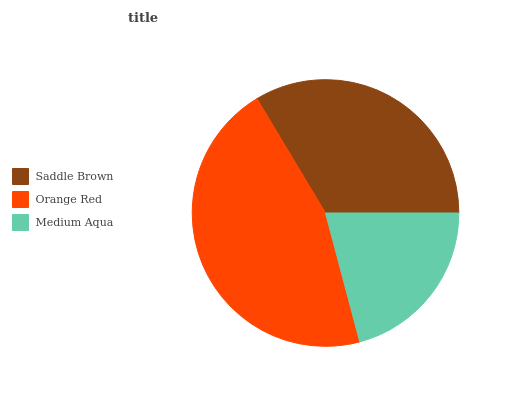Is Medium Aqua the minimum?
Answer yes or no. Yes. Is Orange Red the maximum?
Answer yes or no. Yes. Is Orange Red the minimum?
Answer yes or no. No. Is Medium Aqua the maximum?
Answer yes or no. No. Is Orange Red greater than Medium Aqua?
Answer yes or no. Yes. Is Medium Aqua less than Orange Red?
Answer yes or no. Yes. Is Medium Aqua greater than Orange Red?
Answer yes or no. No. Is Orange Red less than Medium Aqua?
Answer yes or no. No. Is Saddle Brown the high median?
Answer yes or no. Yes. Is Saddle Brown the low median?
Answer yes or no. Yes. Is Medium Aqua the high median?
Answer yes or no. No. Is Medium Aqua the low median?
Answer yes or no. No. 